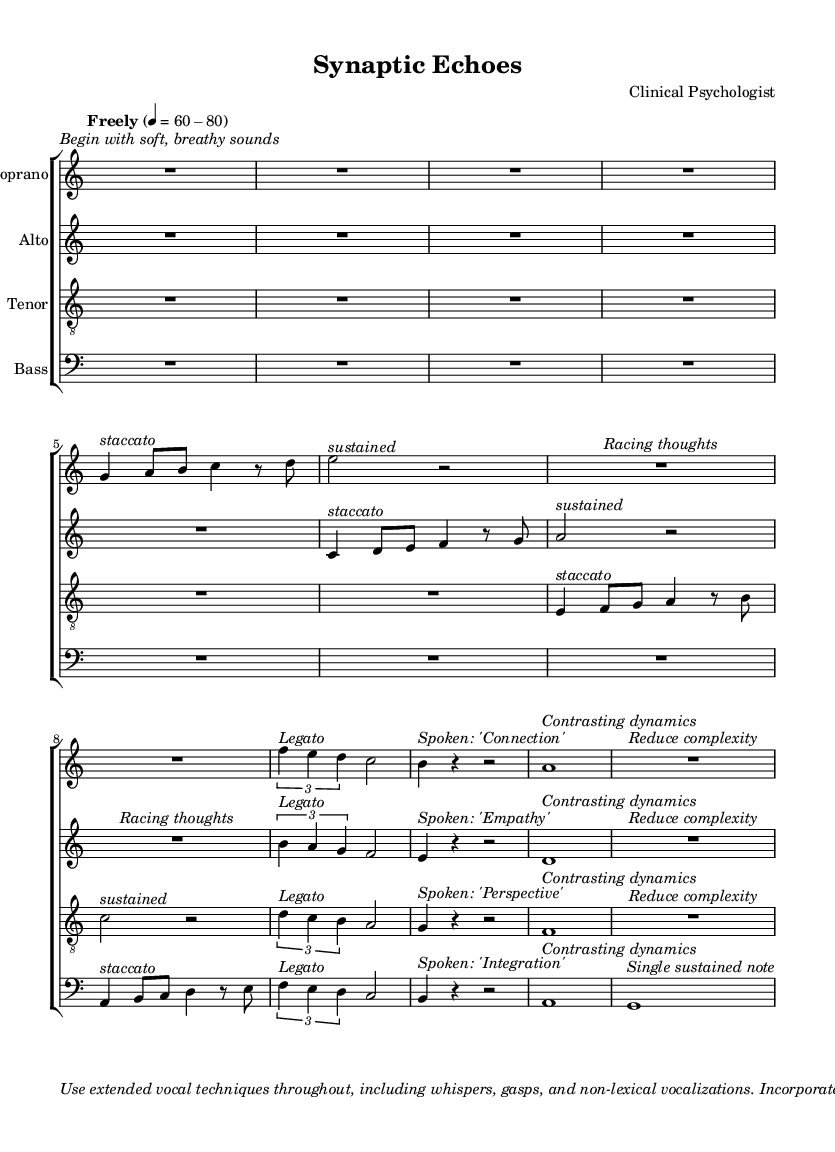What is the time signature of this music? The time signature is indicated at the beginning of the score, presented as 4/4.
Answer: 4/4 What is the tempo marking given in the sheet music? The tempo marking is found directly under the global section and indicates a free tempo range of 60-80 beats per minute.
Answer: Freely 4 = 60-80 What vocal techniques are suggested in the performance notes? The performance notes within the markup section include "whispers," "gasps," and "non-lexical vocalizations," indicating the use of extended vocal techniques.
Answer: Whispers, gasps, non-lexical vocalizations Which voice part has the lyric "Connection"? The lyric "Connection" is spoken in the sopranoMusic section, specifically noted next to a rhythmic cue.
Answer: Soprano How many measures are in the tenorMusic section? To find the measures in tenorMusic, we count each distinct set of notes or rests framed by the bar lines. There are 7 measures in total.
Answer: 7 What is the primary focus of the contrasting dynamics in the bassMusic? The dynamic markings suggest varying intensity throughout the piece, emphasizing different mental states named, specifically leading to a "Single sustained note" at the end.
Answer: Single sustained note How does the score suggest representing different mental states? The score includes diverse vocal textures and dynamics to represent different mental states, as explained in the markup at the end. This is particularly demonstrated by the instructions for varying techniques and the emotional implications of each part.
Answer: Contrasting vocal textures and dynamics 